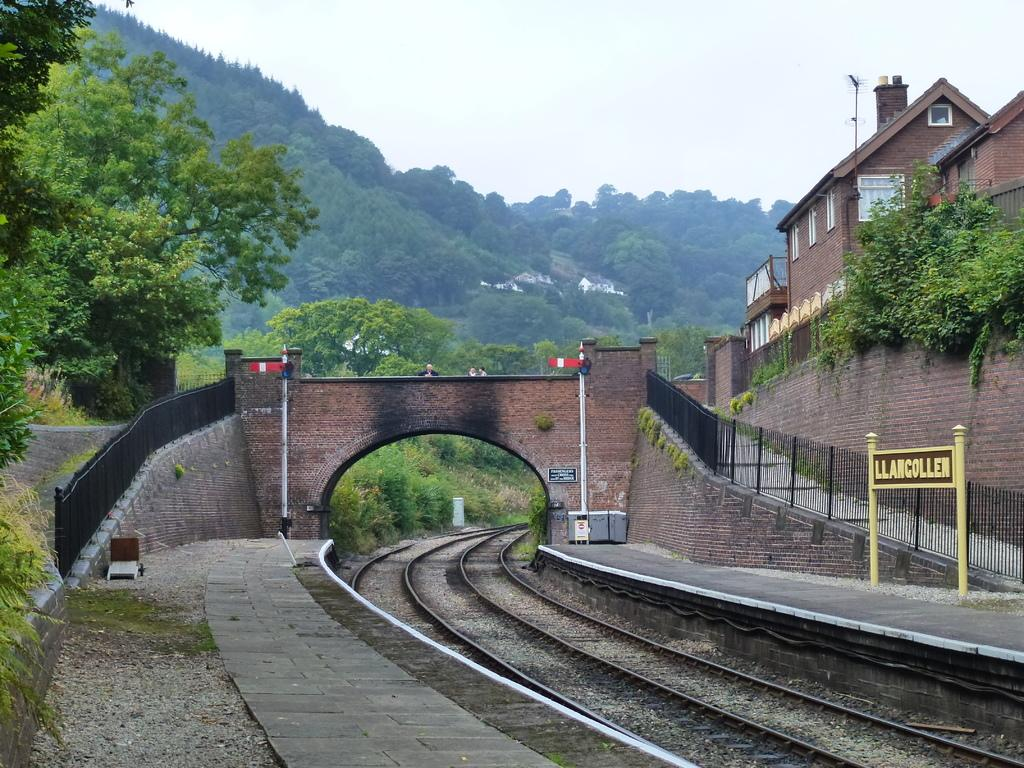<image>
Write a terse but informative summary of the picture. A train track stretches into the distance and a sign says Llancollen next to it. 